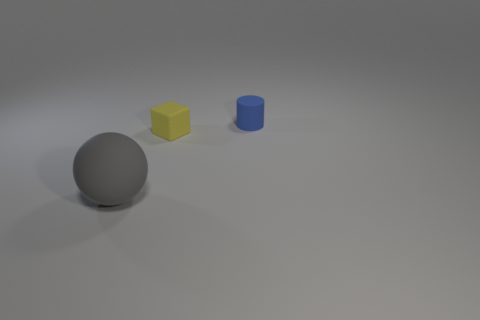There is a matte object that is on the right side of the gray thing and on the left side of the tiny blue thing; what is its size?
Offer a very short reply. Small. What shape is the small yellow rubber object?
Keep it short and to the point. Cube. How many objects are blue rubber balls or rubber things behind the cube?
Ensure brevity in your answer.  1. Do the tiny rubber object that is on the left side of the small blue matte cylinder and the large object have the same color?
Make the answer very short. No. There is a matte object that is to the right of the big rubber sphere and in front of the blue matte cylinder; what is its color?
Provide a short and direct response. Yellow. There is a tiny thing on the left side of the cylinder; what is its material?
Your answer should be very brief. Rubber. The ball is what size?
Make the answer very short. Large. What number of green things are matte objects or tiny cylinders?
Keep it short and to the point. 0. What size is the thing that is right of the tiny object in front of the blue thing?
Ensure brevity in your answer.  Small. Is the color of the cylinder the same as the tiny object in front of the small matte cylinder?
Make the answer very short. No. 